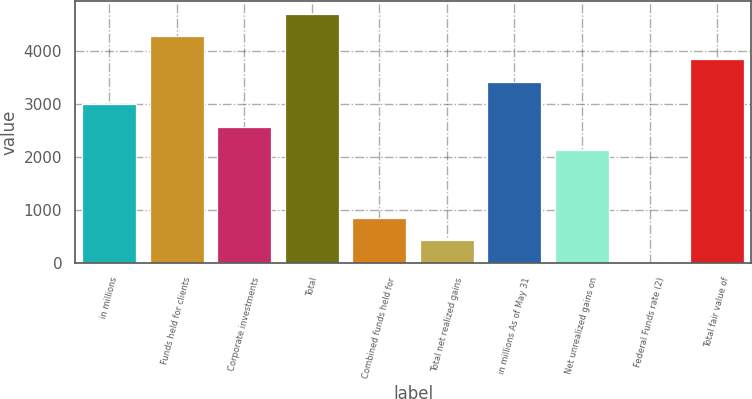Convert chart to OTSL. <chart><loc_0><loc_0><loc_500><loc_500><bar_chart><fcel>in millions<fcel>Funds held for clients<fcel>Corporate investments<fcel>Total<fcel>Combined funds held for<fcel>Total net realized gains<fcel>in millions As of May 31<fcel>Net unrealized gains on<fcel>Federal Funds rate (2)<fcel>Total fair value of<nl><fcel>2989.22<fcel>4270.19<fcel>2562.23<fcel>4697.18<fcel>854.25<fcel>427.25<fcel>3416.21<fcel>2135.24<fcel>0.25<fcel>3843.2<nl></chart> 